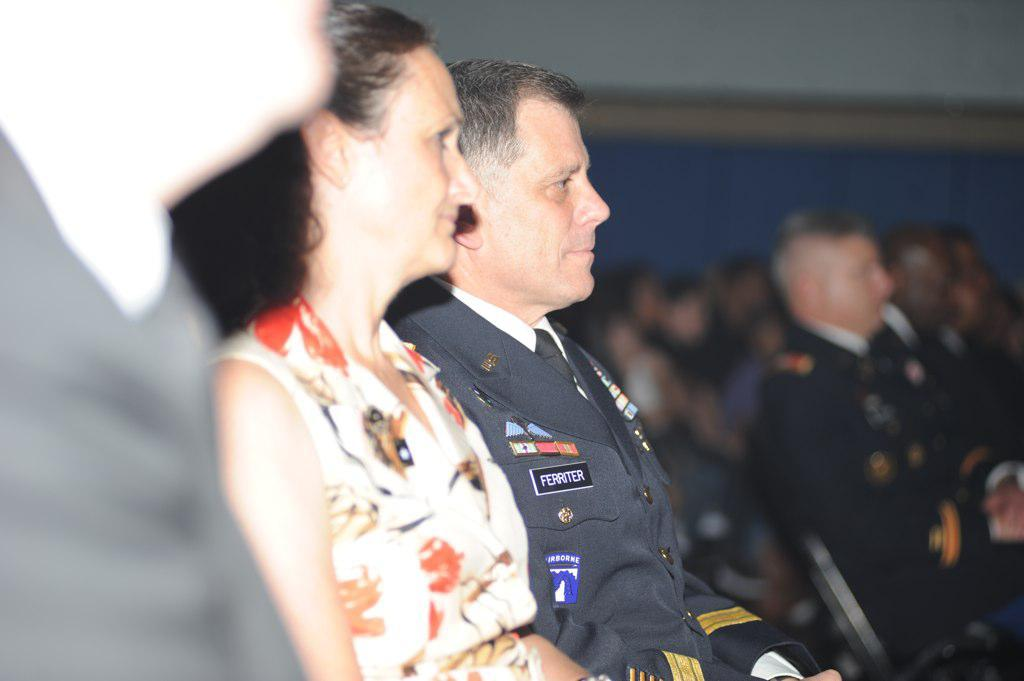What is the gender of the person in the image wearing a dress? The person in the image wearing a dress is a woman. What is the woman wearing in the image? The woman is wearing a dress. What is the man in the image wearing? The man is wearing a uniform. What are the woman and man doing in the image? The woman and man are sitting. How is the background of the image depicted? The background of the image is blurred. Can you describe the people sitting in the background? There are a few more people sitting in the background. What type of tree can be seen in the image? There is no tree present in the image. What is the woman and man are doing with the stone in the image? There is no stone present in the image; the woman and man are sitting. 